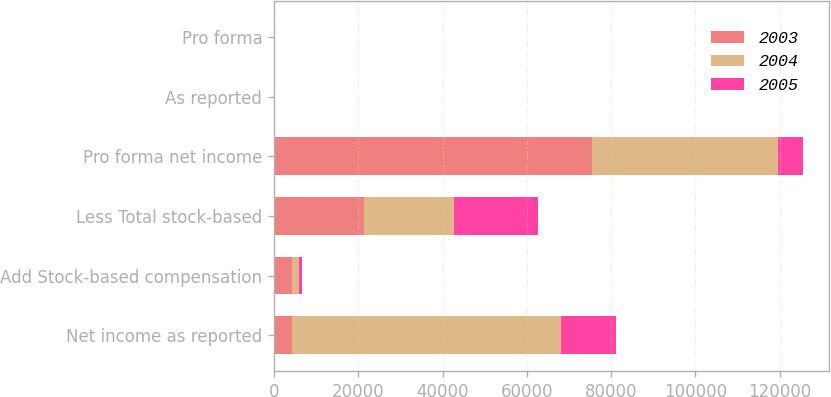Convert chart to OTSL. <chart><loc_0><loc_0><loc_500><loc_500><stacked_bar_chart><ecel><fcel>Net income as reported<fcel>Add Stock-based compensation<fcel>Less Total stock-based<fcel>Pro forma net income<fcel>As reported<fcel>Pro forma<nl><fcel>2003<fcel>4299<fcel>4299<fcel>21434<fcel>75402<fcel>2.64<fcel>2.15<nl><fcel>2004<fcel>63866<fcel>1620<fcel>21388<fcel>44098<fcel>1.81<fcel>1.25<nl><fcel>2005<fcel>13042<fcel>772<fcel>19780<fcel>5966<fcel>0.36<fcel>0.17<nl></chart> 